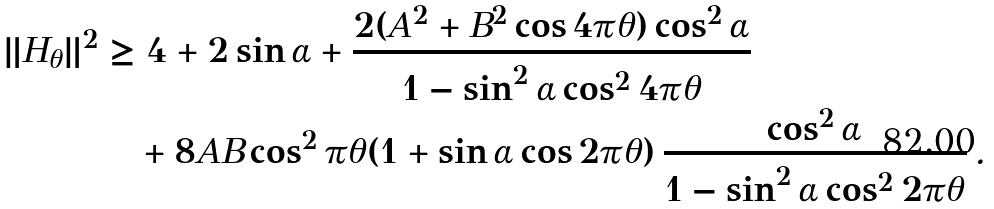<formula> <loc_0><loc_0><loc_500><loc_500>\| H _ { \theta } \| ^ { 2 } & \geq 4 + 2 \sin \alpha + \frac { 2 ( A ^ { 2 } + B ^ { 2 } \cos 4 \pi \theta ) \cos ^ { 2 } \alpha } { 1 - \sin ^ { 2 } \alpha \cos ^ { 2 } 4 \pi \theta } \\ & \quad + 8 A B \cos ^ { 2 } \pi \theta ( 1 + \sin \alpha \cos 2 \pi \theta ) \, \frac { \cos ^ { 2 } \alpha } { 1 - \sin ^ { 2 } \alpha \cos ^ { 2 } 2 \pi \theta } \, .</formula> 